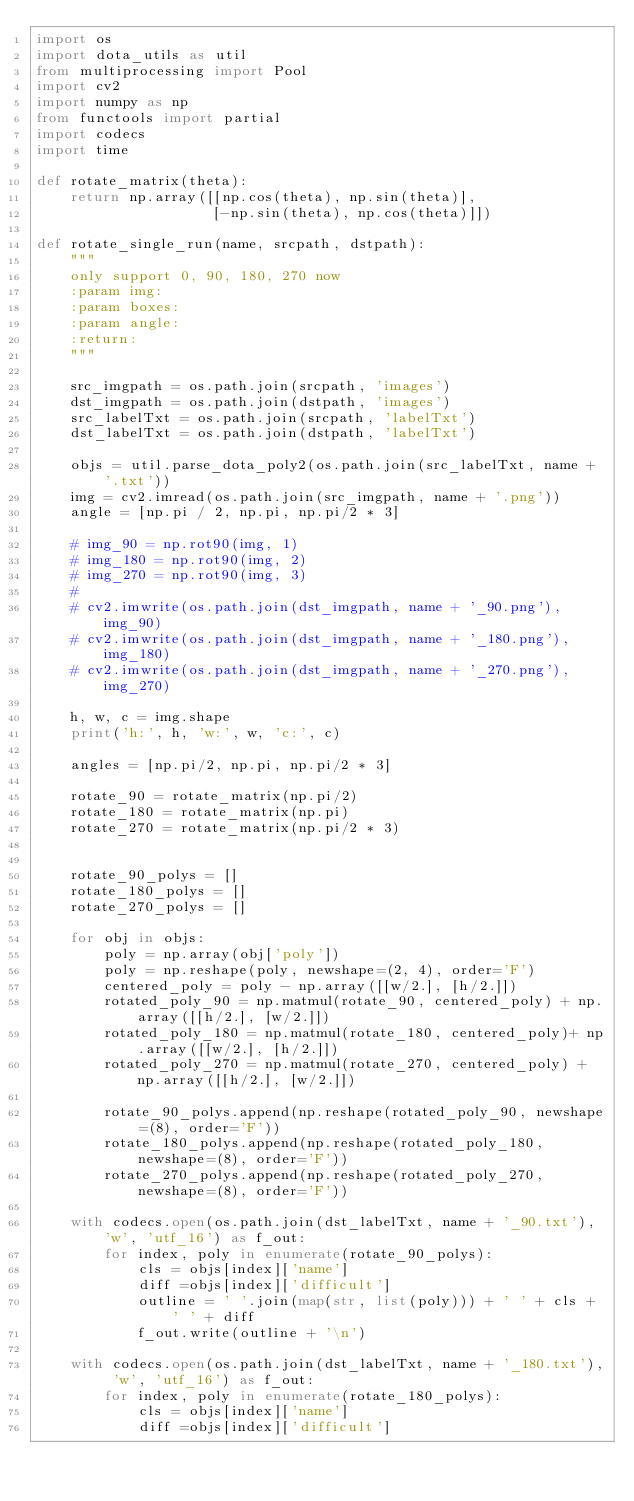Convert code to text. <code><loc_0><loc_0><loc_500><loc_500><_Python_>import os
import dota_utils as util
from multiprocessing import Pool
import cv2
import numpy as np
from functools import partial
import codecs
import time

def rotate_matrix(theta):
    return np.array([[np.cos(theta), np.sin(theta)],
                     [-np.sin(theta), np.cos(theta)]])

def rotate_single_run(name, srcpath, dstpath):
    """
    only support 0, 90, 180, 270 now
    :param img:
    :param boxes:
    :param angle:
    :return:
    """

    src_imgpath = os.path.join(srcpath, 'images')
    dst_imgpath = os.path.join(dstpath, 'images')
    src_labelTxt = os.path.join(srcpath, 'labelTxt')
    dst_labelTxt = os.path.join(dstpath, 'labelTxt')

    objs = util.parse_dota_poly2(os.path.join(src_labelTxt, name + '.txt'))
    img = cv2.imread(os.path.join(src_imgpath, name + '.png'))
    angle = [np.pi / 2, np.pi, np.pi/2 * 3]

    # img_90 = np.rot90(img, 1)
    # img_180 = np.rot90(img, 2)
    # img_270 = np.rot90(img, 3)
    #
    # cv2.imwrite(os.path.join(dst_imgpath, name + '_90.png'), img_90)
    # cv2.imwrite(os.path.join(dst_imgpath, name + '_180.png'), img_180)
    # cv2.imwrite(os.path.join(dst_imgpath, name + '_270.png'), img_270)

    h, w, c = img.shape
    print('h:', h, 'w:', w, 'c:', c)

    angles = [np.pi/2, np.pi, np.pi/2 * 3]

    rotate_90 = rotate_matrix(np.pi/2)
    rotate_180 = rotate_matrix(np.pi)
    rotate_270 = rotate_matrix(np.pi/2 * 3)


    rotate_90_polys = []
    rotate_180_polys = []
    rotate_270_polys = []

    for obj in objs:
        poly = np.array(obj['poly'])
        poly = np.reshape(poly, newshape=(2, 4), order='F')
        centered_poly = poly - np.array([[w/2.], [h/2.]])
        rotated_poly_90 = np.matmul(rotate_90, centered_poly) + np.array([[h/2.], [w/2.]])
        rotated_poly_180 = np.matmul(rotate_180, centered_poly)+ np.array([[w/2.], [h/2.]])
        rotated_poly_270 = np.matmul(rotate_270, centered_poly) + np.array([[h/2.], [w/2.]])

        rotate_90_polys.append(np.reshape(rotated_poly_90, newshape=(8), order='F'))
        rotate_180_polys.append(np.reshape(rotated_poly_180, newshape=(8), order='F'))
        rotate_270_polys.append(np.reshape(rotated_poly_270, newshape=(8), order='F'))

    with codecs.open(os.path.join(dst_labelTxt, name + '_90.txt'), 'w', 'utf_16') as f_out:
        for index, poly in enumerate(rotate_90_polys):
            cls = objs[index]['name']
            diff =objs[index]['difficult']
            outline = ' '.join(map(str, list(poly))) + ' ' + cls + ' ' + diff
            f_out.write(outline + '\n')

    with codecs.open(os.path.join(dst_labelTxt, name + '_180.txt'), 'w', 'utf_16') as f_out:
        for index, poly in enumerate(rotate_180_polys):
            cls = objs[index]['name']
            diff =objs[index]['difficult']</code> 